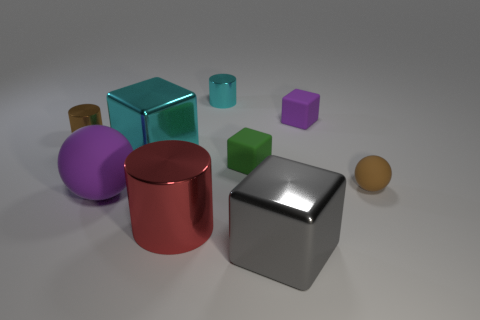How many objects are there, and can you describe their shapes? There are a total of nine objects in the image, consisting of a variety of geometric shapes such as cylinders, cubes, a sphere, and what appears to be a rectangular prism. 